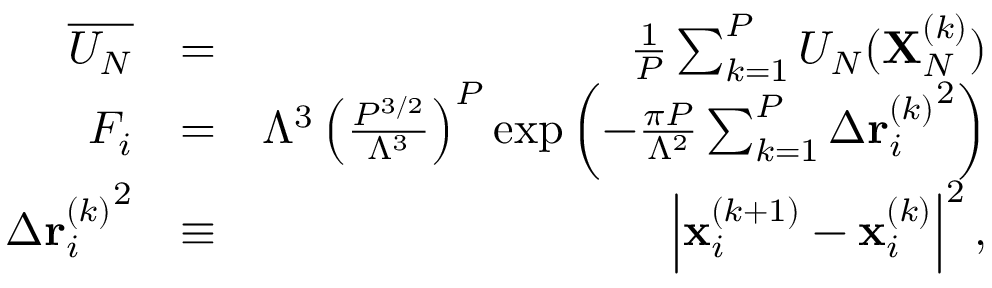<formula> <loc_0><loc_0><loc_500><loc_500>\begin{array} { r l r } { \overline { { U _ { N } } } } & { = } & { \frac { 1 } { P } \sum _ { k = 1 } ^ { P } U _ { N } ( X _ { N } ^ { ( k ) } ) } \\ { F _ { i } } & { = } & { \Lambda ^ { 3 } \left ( \frac { P ^ { 3 / 2 } } { \Lambda ^ { 3 } } \right ) ^ { P } \exp \left ( - \frac { \pi P } { \Lambda ^ { 2 } } \sum _ { k = 1 } ^ { P } \Delta { r _ { i } ^ { ( k ) } } ^ { 2 } \right ) } \\ { \Delta { r _ { i } ^ { ( k ) } } ^ { 2 } } & { \equiv } & { \left | x _ { i } ^ { ( k + 1 ) } - x _ { i } ^ { ( k ) } \right | ^ { 2 } , } \end{array}</formula> 